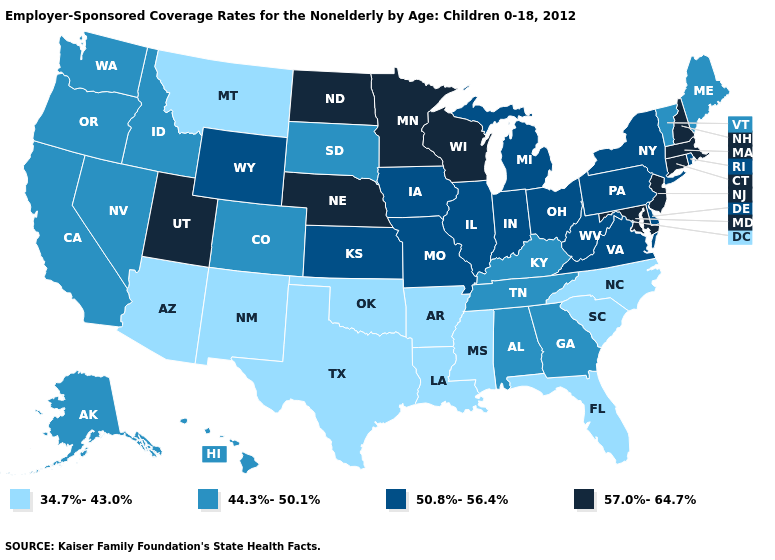What is the value of California?
Write a very short answer. 44.3%-50.1%. What is the lowest value in the Northeast?
Concise answer only. 44.3%-50.1%. Does South Dakota have the lowest value in the MidWest?
Answer briefly. Yes. What is the value of Minnesota?
Be succinct. 57.0%-64.7%. Name the states that have a value in the range 34.7%-43.0%?
Write a very short answer. Arizona, Arkansas, Florida, Louisiana, Mississippi, Montana, New Mexico, North Carolina, Oklahoma, South Carolina, Texas. What is the lowest value in the MidWest?
Give a very brief answer. 44.3%-50.1%. What is the value of Virginia?
Concise answer only. 50.8%-56.4%. Name the states that have a value in the range 50.8%-56.4%?
Concise answer only. Delaware, Illinois, Indiana, Iowa, Kansas, Michigan, Missouri, New York, Ohio, Pennsylvania, Rhode Island, Virginia, West Virginia, Wyoming. What is the highest value in the West ?
Keep it brief. 57.0%-64.7%. How many symbols are there in the legend?
Keep it brief. 4. Which states have the highest value in the USA?
Keep it brief. Connecticut, Maryland, Massachusetts, Minnesota, Nebraska, New Hampshire, New Jersey, North Dakota, Utah, Wisconsin. Which states have the highest value in the USA?
Short answer required. Connecticut, Maryland, Massachusetts, Minnesota, Nebraska, New Hampshire, New Jersey, North Dakota, Utah, Wisconsin. What is the value of South Carolina?
Short answer required. 34.7%-43.0%. What is the value of Indiana?
Quick response, please. 50.8%-56.4%. What is the value of Nevada?
Answer briefly. 44.3%-50.1%. 